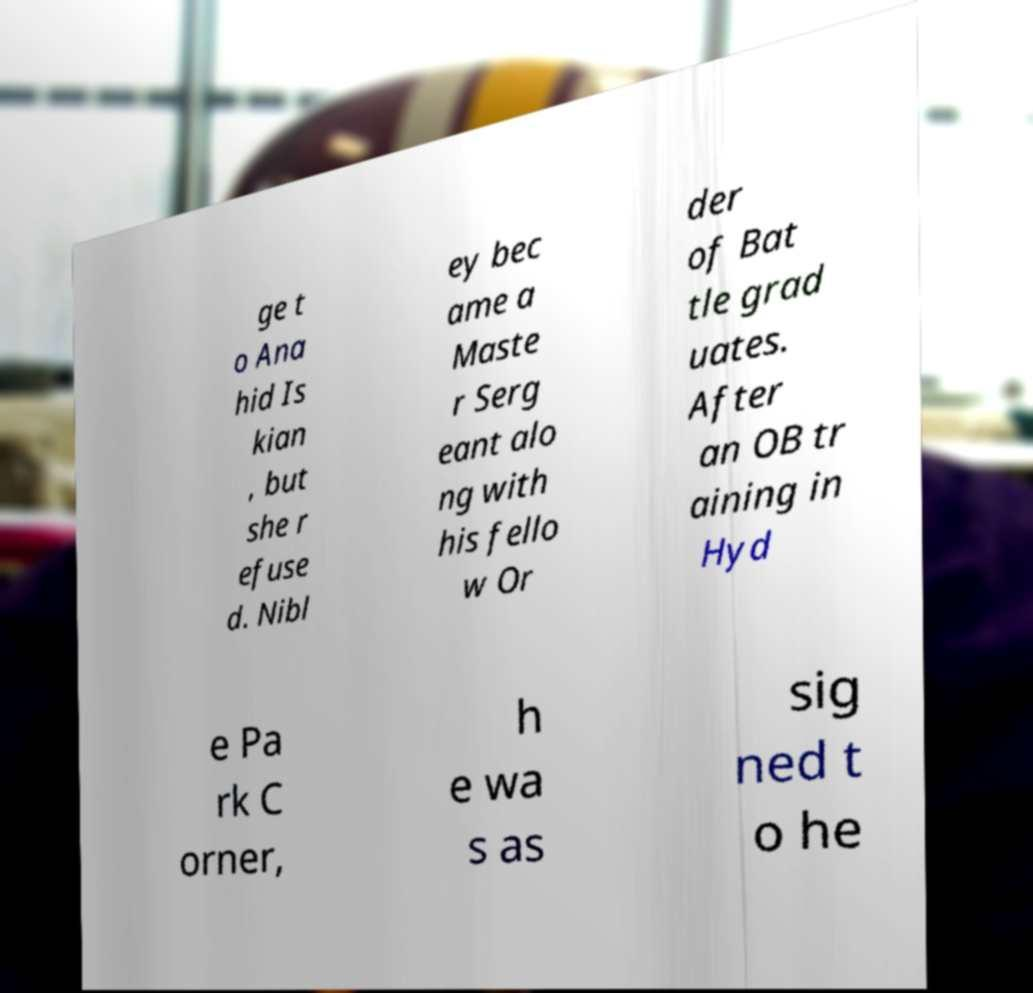Please read and relay the text visible in this image. What does it say? ge t o Ana hid Is kian , but she r efuse d. Nibl ey bec ame a Maste r Serg eant alo ng with his fello w Or der of Bat tle grad uates. After an OB tr aining in Hyd e Pa rk C orner, h e wa s as sig ned t o he 